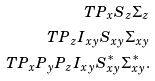Convert formula to latex. <formula><loc_0><loc_0><loc_500><loc_500>T P _ { x } S _ { z } \Sigma _ { z } \\ T P _ { z } I _ { x y } S _ { x y } \Sigma _ { x y } \\ T P _ { x } P _ { y } P _ { z } I _ { x y } S ^ { * } _ { x y } \Sigma ^ { * } _ { x y } .</formula> 